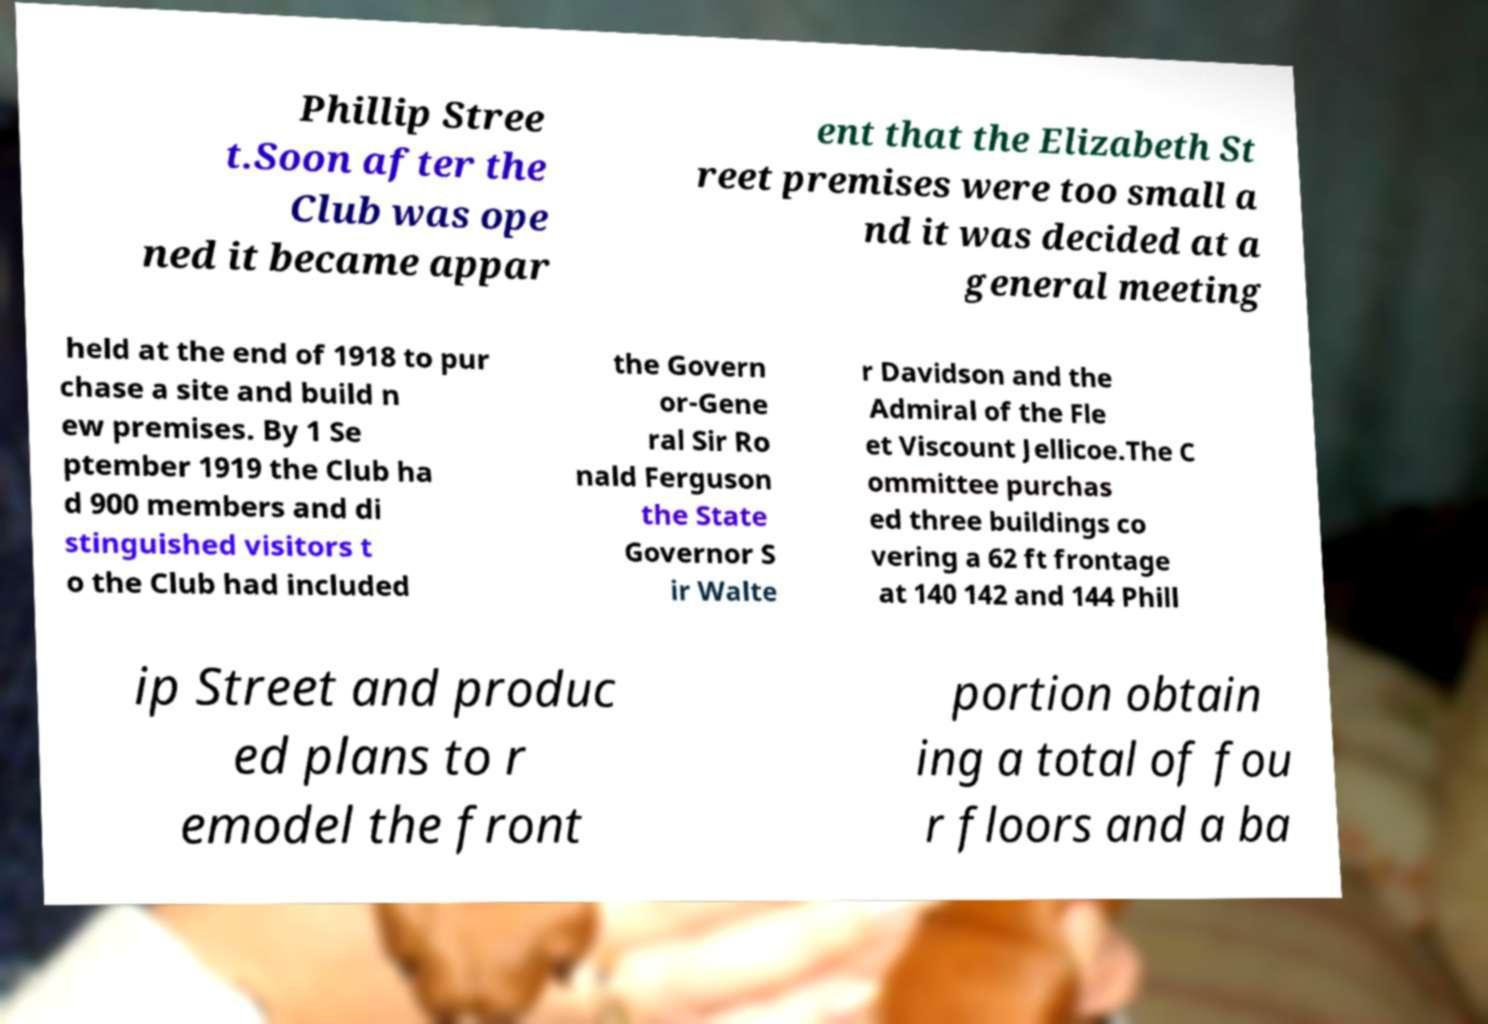Can you read and provide the text displayed in the image?This photo seems to have some interesting text. Can you extract and type it out for me? Phillip Stree t.Soon after the Club was ope ned it became appar ent that the Elizabeth St reet premises were too small a nd it was decided at a general meeting held at the end of 1918 to pur chase a site and build n ew premises. By 1 Se ptember 1919 the Club ha d 900 members and di stinguished visitors t o the Club had included the Govern or-Gene ral Sir Ro nald Ferguson the State Governor S ir Walte r Davidson and the Admiral of the Fle et Viscount Jellicoe.The C ommittee purchas ed three buildings co vering a 62 ft frontage at 140 142 and 144 Phill ip Street and produc ed plans to r emodel the front portion obtain ing a total of fou r floors and a ba 